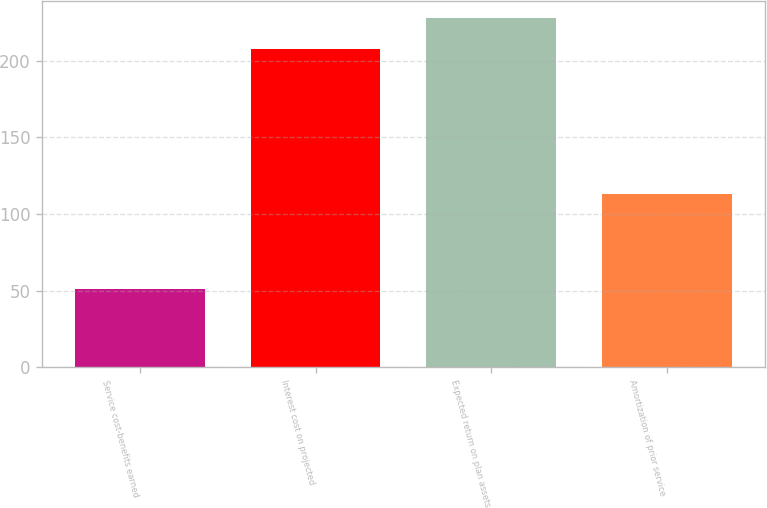Convert chart to OTSL. <chart><loc_0><loc_0><loc_500><loc_500><bar_chart><fcel>Service cost-benefits earned<fcel>Interest cost on projected<fcel>Expected return on plan assets<fcel>Amortization of prior service<nl><fcel>51<fcel>208<fcel>228<fcel>113<nl></chart> 